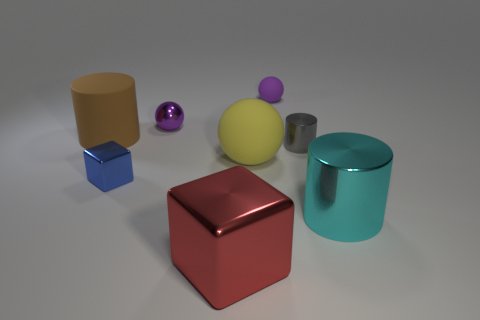How do the lighting and shadows contribute to the overall feel of the image? The lighting in the image is soft and diffuse, casting gentle shadows that lend a tranquil and balanced ambiance to the scene. The shadows also establish the spatial relationships between objects and enhance the three-dimensional perception of the array. 